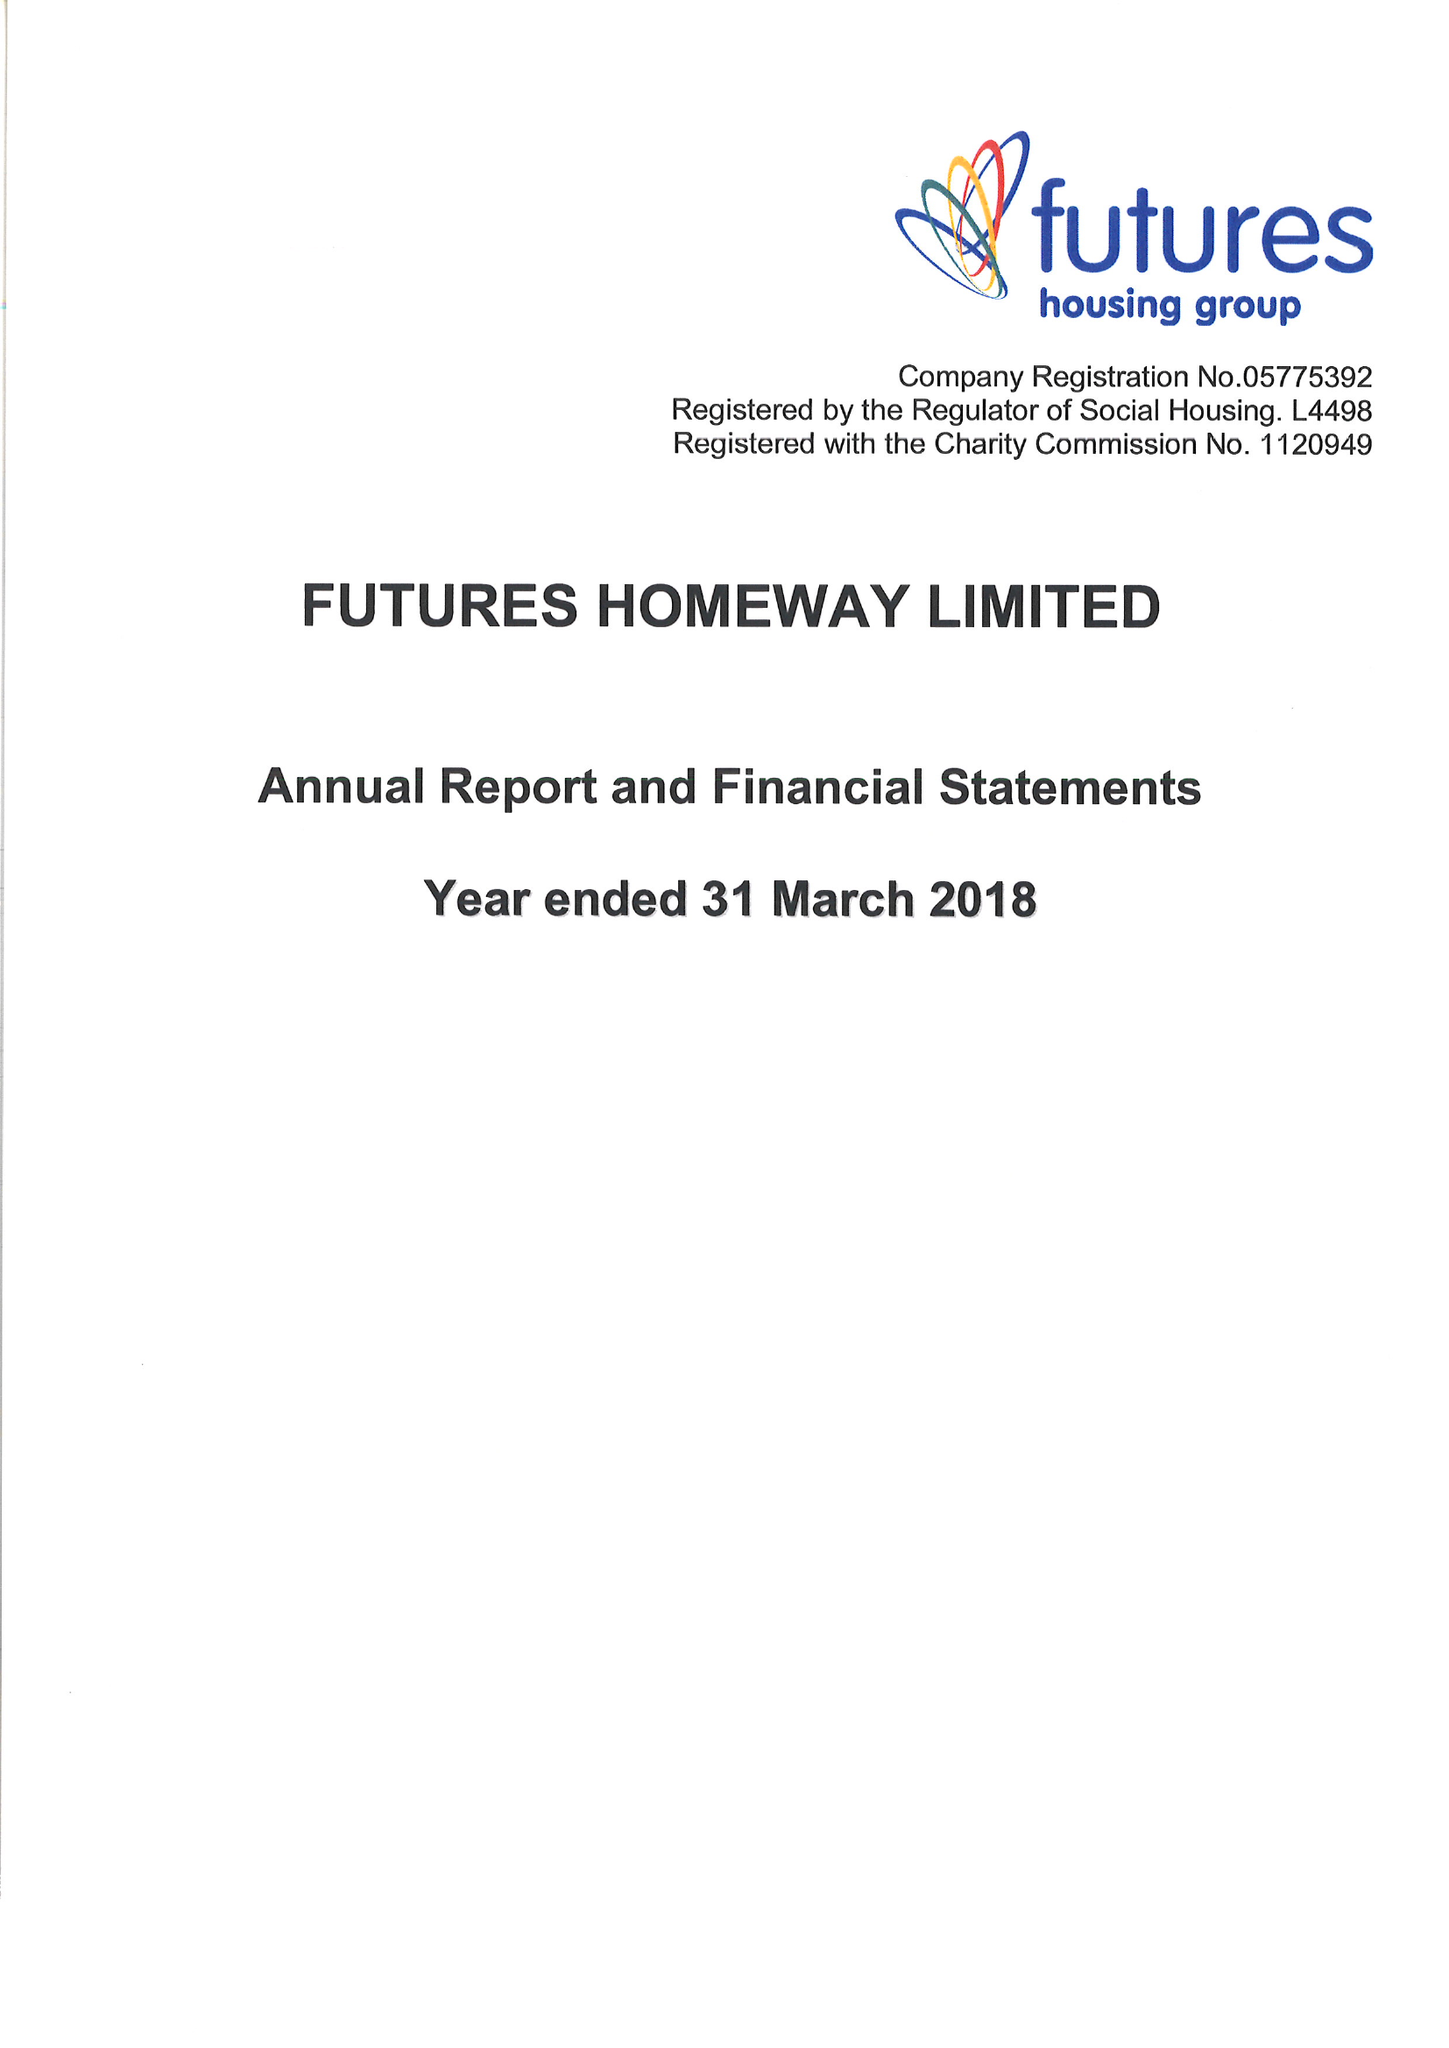What is the value for the spending_annually_in_british_pounds?
Answer the question using a single word or phrase. 11910000.00 